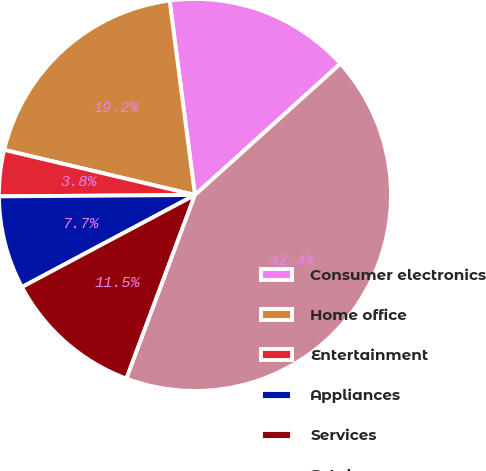Convert chart to OTSL. <chart><loc_0><loc_0><loc_500><loc_500><pie_chart><fcel>Consumer electronics<fcel>Home office<fcel>Entertainment<fcel>Appliances<fcel>Services<fcel>Total<nl><fcel>15.38%<fcel>19.24%<fcel>3.81%<fcel>7.67%<fcel>11.53%<fcel>42.37%<nl></chart> 